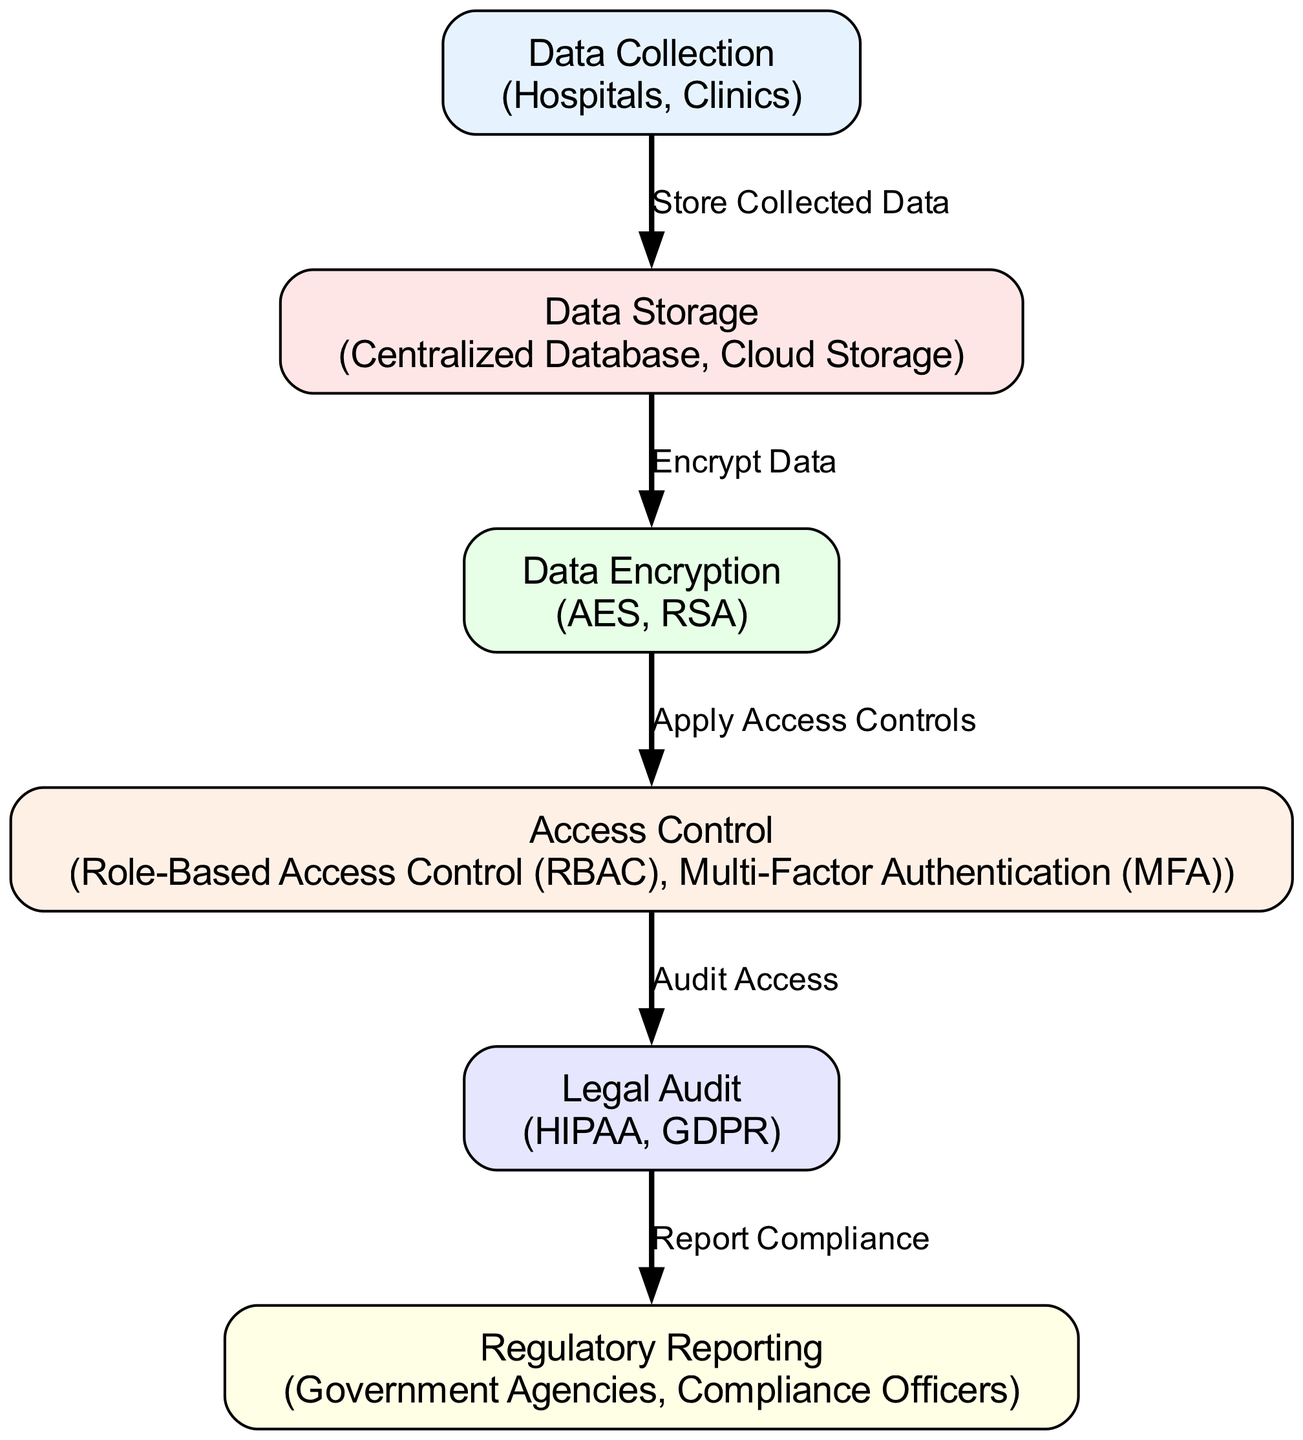What is the first step in data privacy compliance for hospitals? The first step is "Data Collection," where patient data is initially collected by hospitals and clinics. This is clearly labeled as the starting point in the diagram.
Answer: Data Collection What is the last step in data privacy compliance shown in the diagram? The last step is "Regulatory Reporting," which involves reporting compliance status to regulators, as depicted in the diagram.
Answer: Regulatory Reporting How many nodes are there in the data privacy compliance schematic? By counting the distinct labeled nodes in the diagram, there are six nodes representing different steps in the process.
Answer: Six What follows "Data Encryption" in the compliance process? "Access Control" directly follows "Data Encryption" in the flow of the diagram, indicating that access controls are applied after data is encrypted.
Answer: Access Control Which entities are involved in "Legal Audit"? The entities involved in "Legal Audit" include "HIPAA" and "GDPR," both of which are regulatory standards tied to legal compliance, as shown in the node description.
Answer: HIPAA, GDPR What type of access control methods are mentioned in the diagram? The diagram mentions "Role-Based Access Control (RBAC)" and "Multi-Factor Authentication (MFA)" as the methods used for controlling access to sensitive patient data.
Answer: Role-Based Access Control, Multi-Factor Authentication Which step comes after "Access Control" in the compliance process? The step that comes after "Access Control" is "Legal Audit," which is part of ensuring that access to data is regularly audited for compliance.
Answer: Legal Audit What is the relationship between "Legal Audit" and "Regulatory Reporting"? The relationship is that "Legal Audit" leads to "Regulatory Reporting," meaning that the results of legal audits are used to report compliance to regulatory agencies.
Answer: Report Compliance What type of database is used for "Data Storage"? The diagram specifies that "Centralized Database" and "Cloud Storage" are the forms of data storage utilized for secure patient data.
Answer: Centralized Database, Cloud Storage 